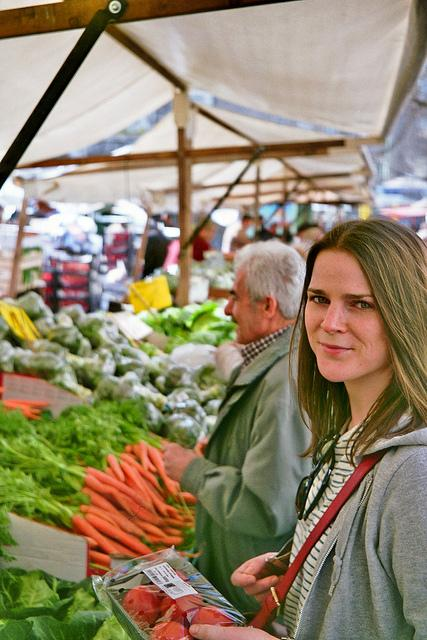Which food contains the most vitamin A? Please explain your reasoning. carrot. The carrots on the produce stand are very high in vitamin a. 